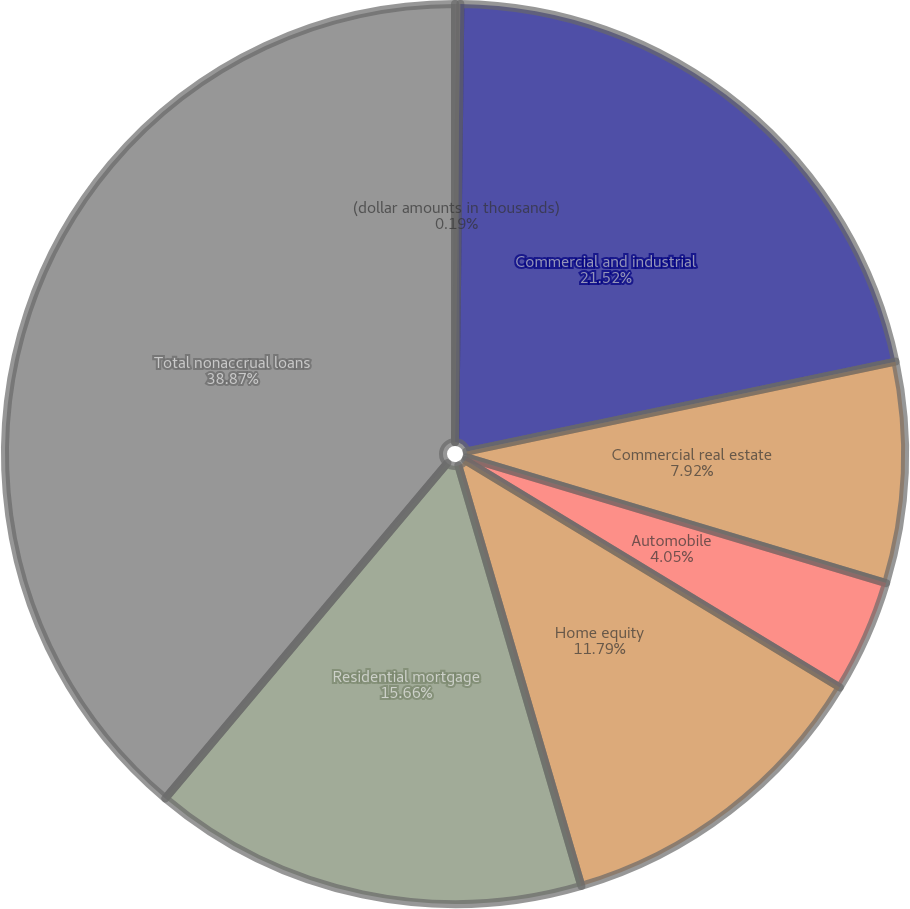Convert chart to OTSL. <chart><loc_0><loc_0><loc_500><loc_500><pie_chart><fcel>(dollar amounts in thousands)<fcel>Commercial and industrial<fcel>Commercial real estate<fcel>Automobile<fcel>Home equity<fcel>Residential mortgage<fcel>Total nonaccrual loans<nl><fcel>0.19%<fcel>21.52%<fcel>7.92%<fcel>4.05%<fcel>11.79%<fcel>15.66%<fcel>38.87%<nl></chart> 